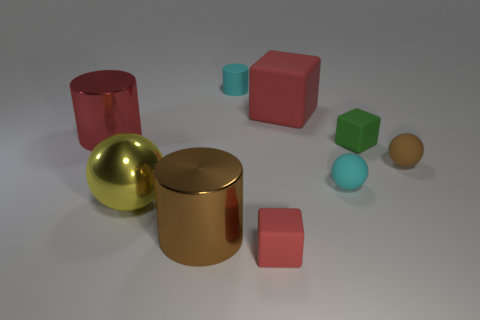What number of objects are cyan things that are right of the small red rubber object or large objects to the right of the tiny cyan cylinder?
Ensure brevity in your answer.  2. Are there more big blue metallic balls than small rubber cubes?
Your answer should be compact. No. The large metallic cylinder that is left of the brown cylinder is what color?
Give a very brief answer. Red. Is the big red rubber object the same shape as the green thing?
Provide a short and direct response. Yes. The object that is both left of the small red rubber thing and on the right side of the brown metallic cylinder is what color?
Give a very brief answer. Cyan. Do the metal cylinder left of the brown shiny object and the red object that is in front of the green block have the same size?
Keep it short and to the point. No. What number of things are either tiny rubber things in front of the green rubber cube or small rubber objects?
Give a very brief answer. 5. What is the material of the green block?
Your answer should be very brief. Rubber. Does the cyan matte sphere have the same size as the yellow thing?
Make the answer very short. No. How many blocks are either metallic objects or tiny purple rubber things?
Provide a short and direct response. 0. 